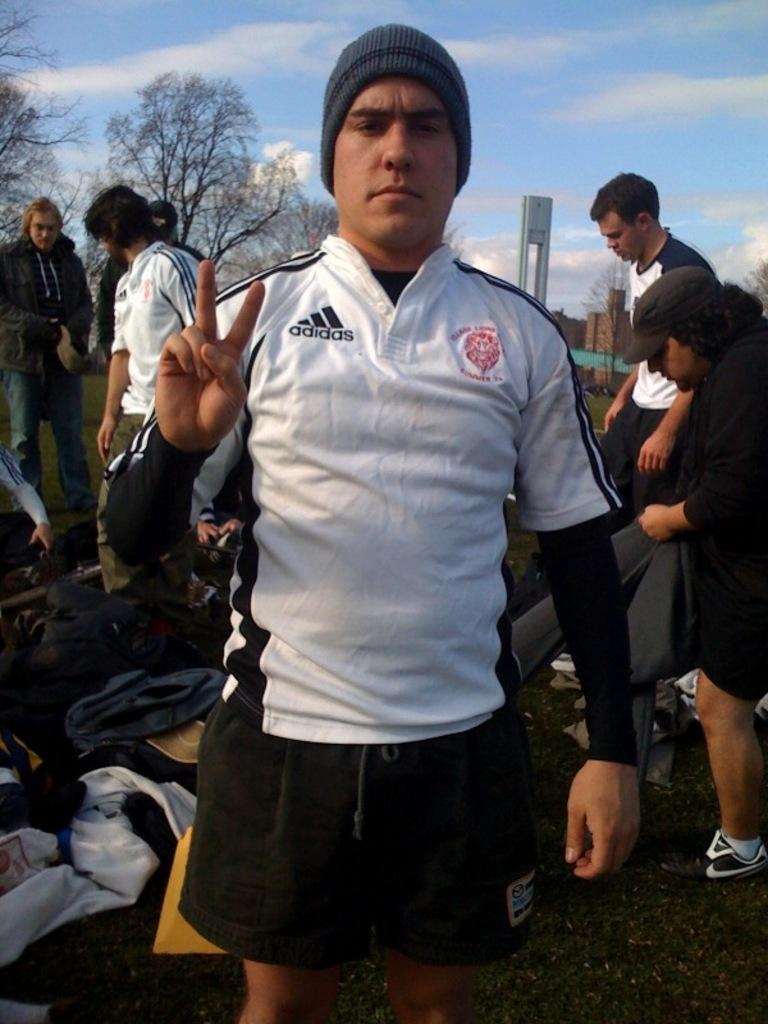<image>
Present a compact description of the photo's key features. A man in a beanie wearing an adidas shirt 